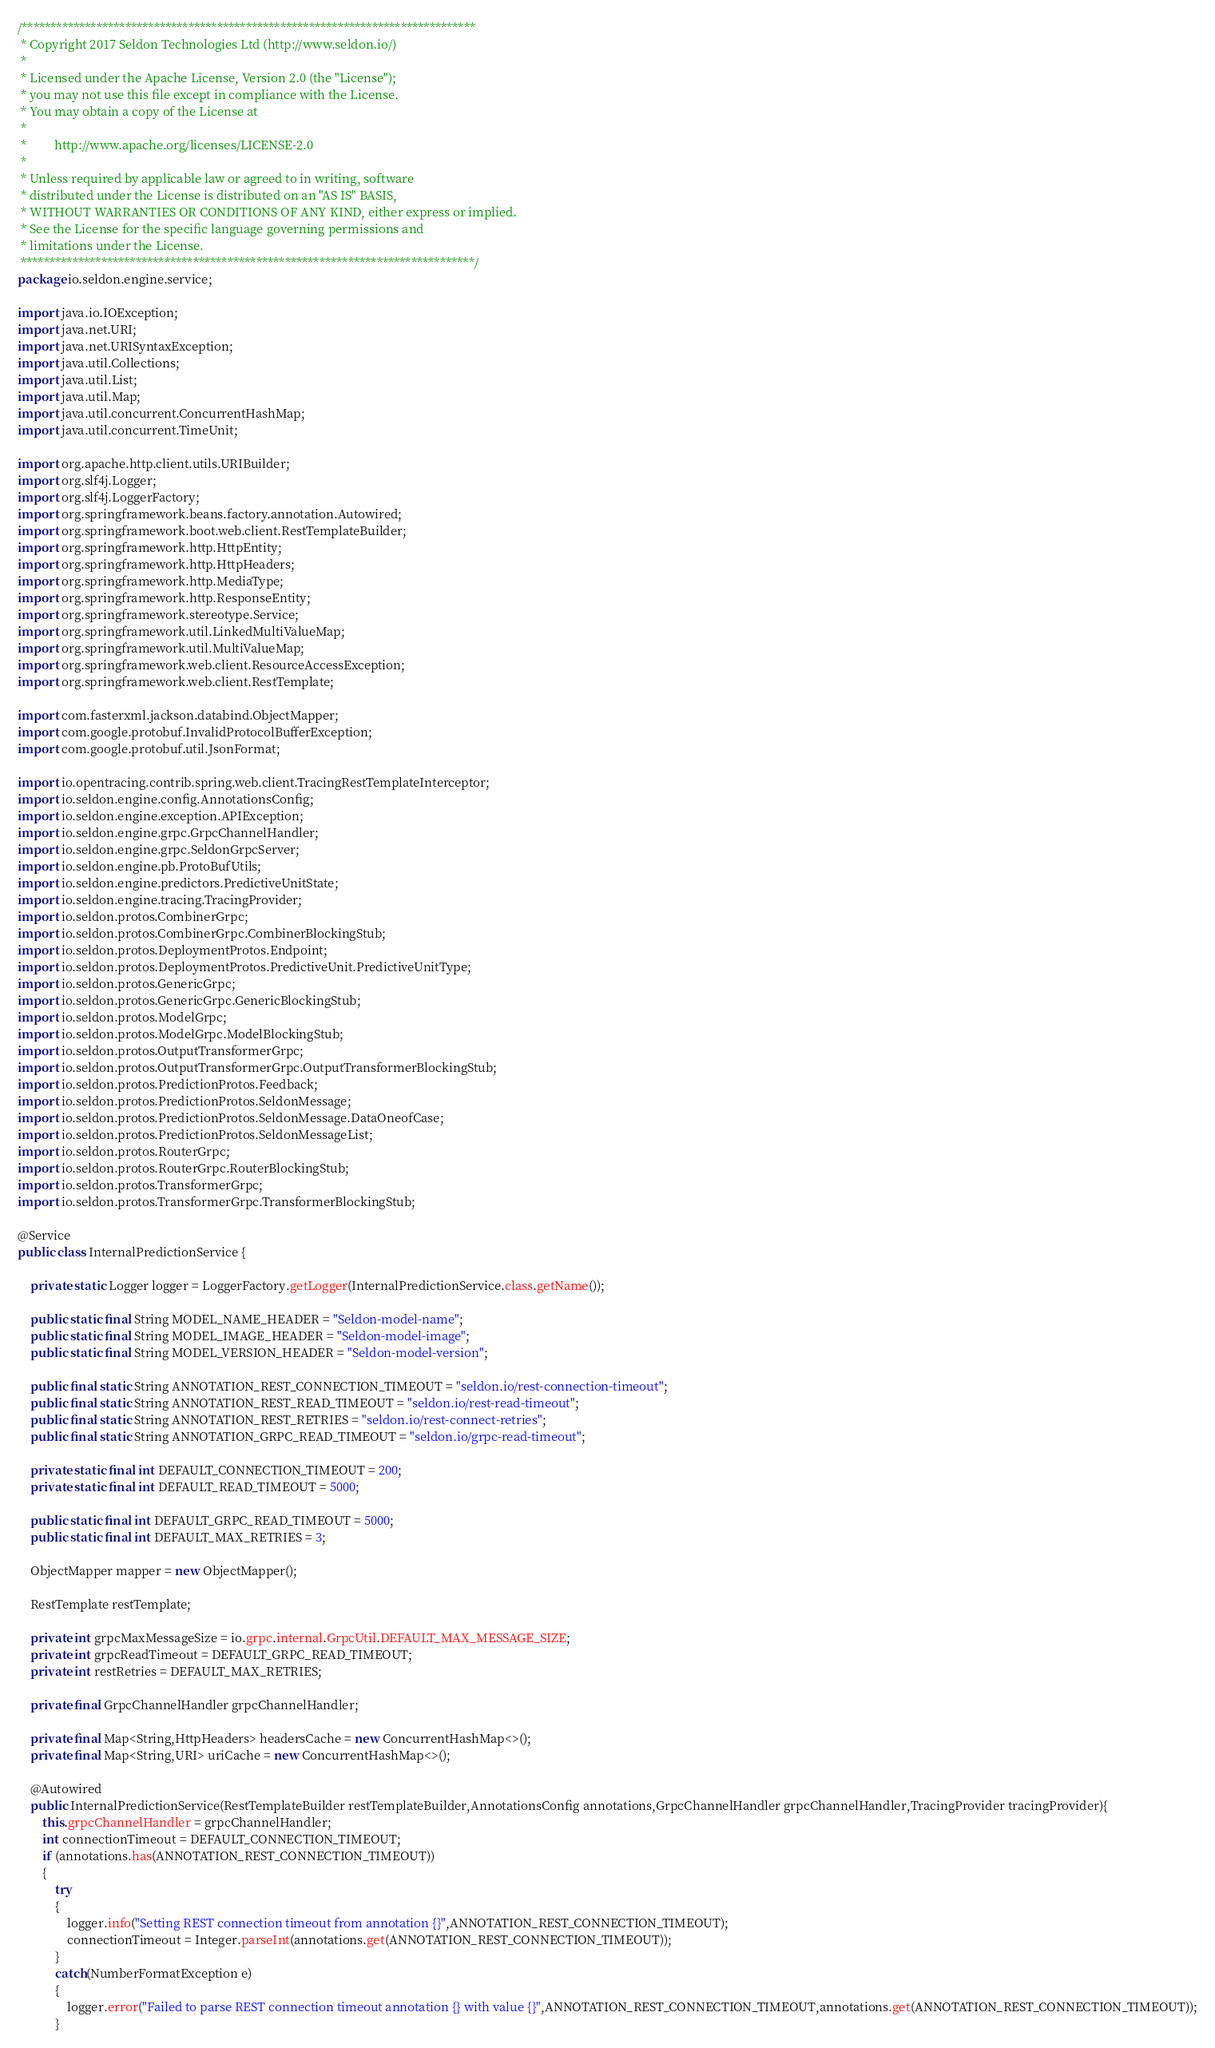<code> <loc_0><loc_0><loc_500><loc_500><_Java_>/*******************************************************************************
 * Copyright 2017 Seldon Technologies Ltd (http://www.seldon.io/)
 *
 * Licensed under the Apache License, Version 2.0 (the "License");
 * you may not use this file except in compliance with the License.
 * You may obtain a copy of the License at
 *
 *         http://www.apache.org/licenses/LICENSE-2.0
 *
 * Unless required by applicable law or agreed to in writing, software
 * distributed under the License is distributed on an "AS IS" BASIS,
 * WITHOUT WARRANTIES OR CONDITIONS OF ANY KIND, either express or implied.
 * See the License for the specific language governing permissions and
 * limitations under the License.
 *******************************************************************************/
package io.seldon.engine.service;

import java.io.IOException;
import java.net.URI;
import java.net.URISyntaxException;
import java.util.Collections;
import java.util.List;
import java.util.Map;
import java.util.concurrent.ConcurrentHashMap;
import java.util.concurrent.TimeUnit;

import org.apache.http.client.utils.URIBuilder;
import org.slf4j.Logger;
import org.slf4j.LoggerFactory;
import org.springframework.beans.factory.annotation.Autowired;
import org.springframework.boot.web.client.RestTemplateBuilder;
import org.springframework.http.HttpEntity;
import org.springframework.http.HttpHeaders;
import org.springframework.http.MediaType;
import org.springframework.http.ResponseEntity;
import org.springframework.stereotype.Service;
import org.springframework.util.LinkedMultiValueMap;
import org.springframework.util.MultiValueMap;
import org.springframework.web.client.ResourceAccessException;
import org.springframework.web.client.RestTemplate;

import com.fasterxml.jackson.databind.ObjectMapper;
import com.google.protobuf.InvalidProtocolBufferException;
import com.google.protobuf.util.JsonFormat;

import io.opentracing.contrib.spring.web.client.TracingRestTemplateInterceptor;
import io.seldon.engine.config.AnnotationsConfig;
import io.seldon.engine.exception.APIException;
import io.seldon.engine.grpc.GrpcChannelHandler;
import io.seldon.engine.grpc.SeldonGrpcServer;
import io.seldon.engine.pb.ProtoBufUtils;
import io.seldon.engine.predictors.PredictiveUnitState;
import io.seldon.engine.tracing.TracingProvider;
import io.seldon.protos.CombinerGrpc;
import io.seldon.protos.CombinerGrpc.CombinerBlockingStub;
import io.seldon.protos.DeploymentProtos.Endpoint;
import io.seldon.protos.DeploymentProtos.PredictiveUnit.PredictiveUnitType;
import io.seldon.protos.GenericGrpc;
import io.seldon.protos.GenericGrpc.GenericBlockingStub;
import io.seldon.protos.ModelGrpc;
import io.seldon.protos.ModelGrpc.ModelBlockingStub;
import io.seldon.protos.OutputTransformerGrpc;
import io.seldon.protos.OutputTransformerGrpc.OutputTransformerBlockingStub;
import io.seldon.protos.PredictionProtos.Feedback;
import io.seldon.protos.PredictionProtos.SeldonMessage;
import io.seldon.protos.PredictionProtos.SeldonMessage.DataOneofCase;
import io.seldon.protos.PredictionProtos.SeldonMessageList;
import io.seldon.protos.RouterGrpc;
import io.seldon.protos.RouterGrpc.RouterBlockingStub;
import io.seldon.protos.TransformerGrpc;
import io.seldon.protos.TransformerGrpc.TransformerBlockingStub;

@Service
public class InternalPredictionService {
	
	private static Logger logger = LoggerFactory.getLogger(InternalPredictionService.class.getName());

	public static final String MODEL_NAME_HEADER = "Seldon-model-name"; 
	public static final String MODEL_IMAGE_HEADER = "Seldon-model-image"; 
	public static final String MODEL_VERSION_HEADER = "Seldon-model-version";
	
    public final static String ANNOTATION_REST_CONNECTION_TIMEOUT = "seldon.io/rest-connection-timeout";
    public final static String ANNOTATION_REST_READ_TIMEOUT = "seldon.io/rest-read-timeout";
    public final static String ANNOTATION_REST_RETRIES = "seldon.io/rest-connect-retries";    
    public final static String ANNOTATION_GRPC_READ_TIMEOUT = "seldon.io/grpc-read-timeout";

	private static final int DEFAULT_CONNECTION_TIMEOUT = 200;
	private static final int DEFAULT_READ_TIMEOUT = 5000;
	
	public static final int DEFAULT_GRPC_READ_TIMEOUT = 5000;
	public static final int DEFAULT_MAX_RETRIES = 3;
	
    ObjectMapper mapper = new ObjectMapper();
    
    RestTemplate restTemplate;
    
    private int grpcMaxMessageSize = io.grpc.internal.GrpcUtil.DEFAULT_MAX_MESSAGE_SIZE;
    private int grpcReadTimeout = DEFAULT_GRPC_READ_TIMEOUT;
    private int restRetries = DEFAULT_MAX_RETRIES;
    
    private final GrpcChannelHandler grpcChannelHandler;
    
    private final Map<String,HttpHeaders> headersCache = new ConcurrentHashMap<>();
    private final Map<String,URI> uriCache = new ConcurrentHashMap<>();
    
    @Autowired
    public InternalPredictionService(RestTemplateBuilder restTemplateBuilder,AnnotationsConfig annotations,GrpcChannelHandler grpcChannelHandler,TracingProvider tracingProvider){
    	this.grpcChannelHandler = grpcChannelHandler;
    	int connectionTimeout = DEFAULT_CONNECTION_TIMEOUT;
    	if (annotations.has(ANNOTATION_REST_CONNECTION_TIMEOUT))
    	{
    		try
    		{
    			logger.info("Setting REST connection timeout from annotation {}",ANNOTATION_REST_CONNECTION_TIMEOUT);
    			connectionTimeout = Integer.parseInt(annotations.get(ANNOTATION_REST_CONNECTION_TIMEOUT));
    		}
    		catch(NumberFormatException e)
    		{
    			logger.error("Failed to parse REST connection timeout annotation {} with value {}",ANNOTATION_REST_CONNECTION_TIMEOUT,annotations.get(ANNOTATION_REST_CONNECTION_TIMEOUT));
    		}</code> 